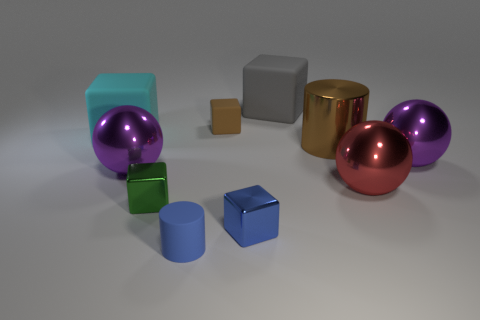Subtract all cyan cubes. How many cubes are left? 4 Subtract all small blue metal blocks. How many blocks are left? 4 Subtract all purple blocks. Subtract all yellow balls. How many blocks are left? 5 Subtract all spheres. How many objects are left? 7 Subtract all big green shiny cubes. Subtract all tiny cubes. How many objects are left? 7 Add 5 large brown shiny cylinders. How many large brown shiny cylinders are left? 6 Add 5 small purple shiny cubes. How many small purple shiny cubes exist? 5 Subtract 0 yellow blocks. How many objects are left? 10 